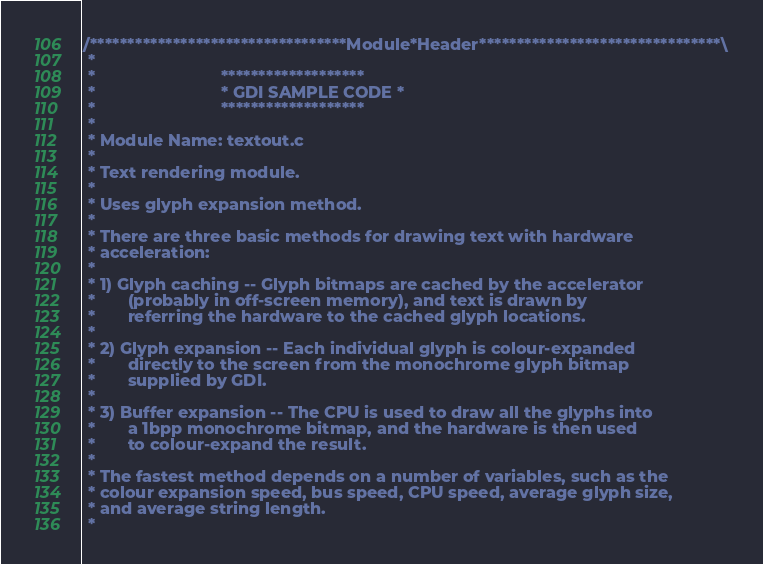<code> <loc_0><loc_0><loc_500><loc_500><_C_>/**********************************Module*Header********************************\
 *
 *                           *******************
 *                           * GDI SAMPLE CODE *
 *                           *******************
 *
 * Module Name: textout.c
 *
 * Text rendering module.
 *
 * Uses glyph expansion method.
 *
 * There are three basic methods for drawing text with hardware
 * acceleration:
 *
 * 1) Glyph caching -- Glyph bitmaps are cached by the accelerator
 *       (probably in off-screen memory), and text is drawn by
 *       referring the hardware to the cached glyph locations.
 * 
 * 2) Glyph expansion -- Each individual glyph is colour-expanded
 *       directly to the screen from the monochrome glyph bitmap
 *       supplied by GDI.
 * 
 * 3) Buffer expansion -- The CPU is used to draw all the glyphs into
 *       a 1bpp monochrome bitmap, and the hardware is then used
 *       to colour-expand the result.
 * 
 * The fastest method depends on a number of variables, such as the
 * colour expansion speed, bus speed, CPU speed, average glyph size,
 * and average string length.
 * </code> 